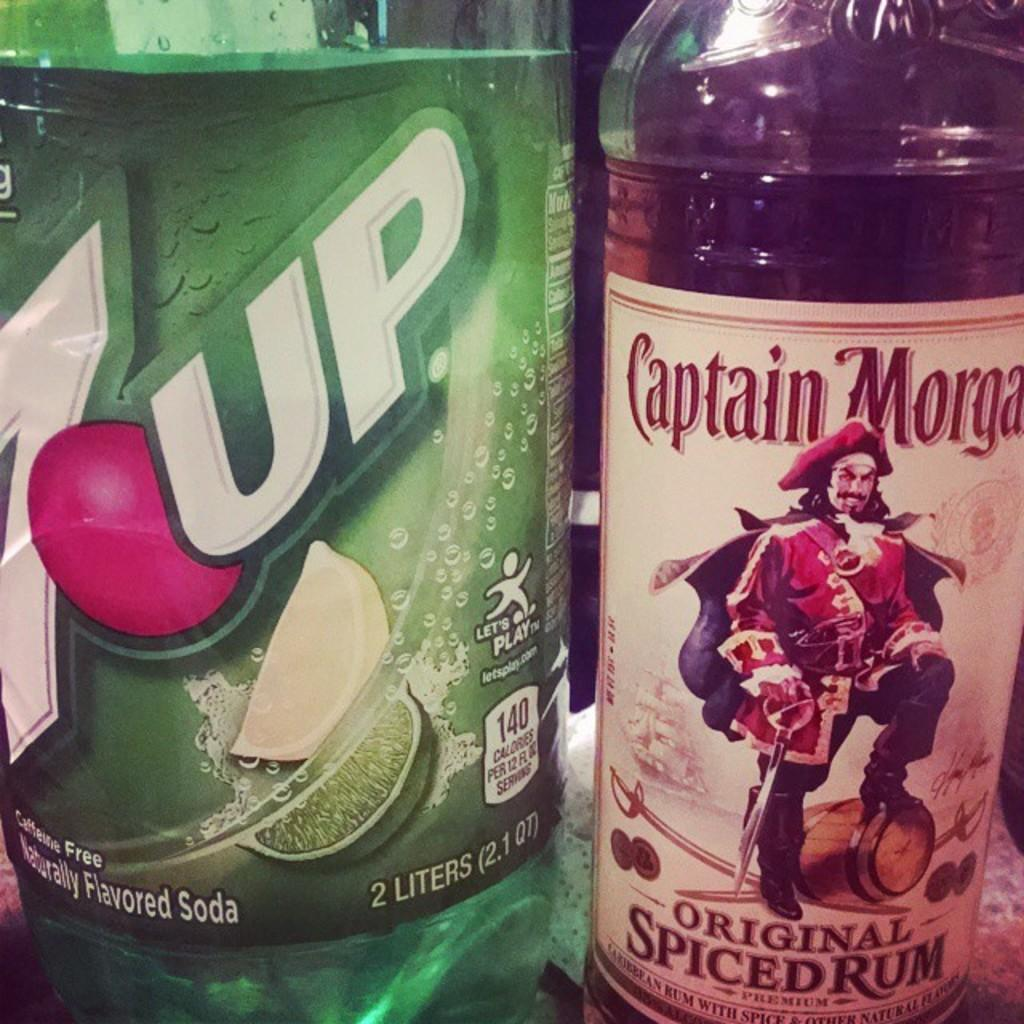<image>
Provide a brief description of the given image. Captain Morgan & Naturally Flavored 7 Up soda. 